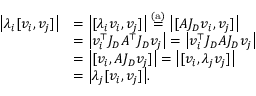<formula> <loc_0><loc_0><loc_500><loc_500>\begin{array} { r l } { \left | \lambda _ { i } [ v _ { i } , v _ { j } ] \right | } & { = \left | [ \lambda _ { i } v _ { i } , v _ { j } ] \right | \stackrel { ( a ) } { = } \left | [ A J _ { D } v _ { i } , v _ { j } ] \right | } \\ & { = \left | v _ { i } ^ { \top } J _ { D } A ^ { \top } J _ { D } v _ { j } \right | = \left | v _ { i } ^ { \top } J _ { D } A J _ { D } v _ { j } \right | } \\ & { = \left | [ v _ { i } , A J _ { D } v _ { j } ] \right | = \left | [ v _ { i } , \lambda _ { j } v _ { j } ] \right | } \\ & { = \left | \lambda _ { j } [ v _ { i } , v _ { j } ] \right | . } \end{array}</formula> 